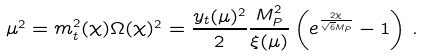Convert formula to latex. <formula><loc_0><loc_0><loc_500><loc_500>\mu ^ { 2 } = m _ { t } ^ { 2 } ( \chi ) \Omega ( \chi ) ^ { 2 } = \frac { y _ { t } ( \mu ) ^ { 2 } } { 2 } \frac { M _ { P } ^ { 2 } } { \xi ( \mu ) } \left ( e ^ { \frac { 2 \chi } { \sqrt { 6 } M _ { P } } } - 1 \right ) \, .</formula> 